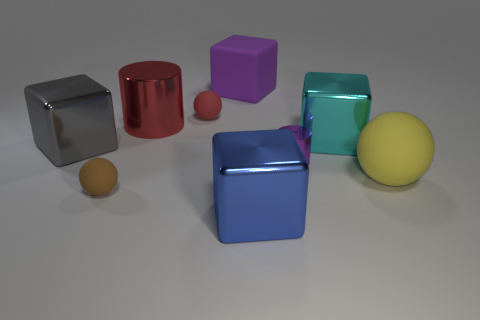Add 1 big gray cubes. How many objects exist? 10 Subtract all yellow cubes. Subtract all red cylinders. How many cubes are left? 4 Subtract all cylinders. How many objects are left? 7 Add 7 red metal things. How many red metal things exist? 8 Subtract 0 yellow cylinders. How many objects are left? 9 Subtract all big yellow spheres. Subtract all big spheres. How many objects are left? 7 Add 2 large gray things. How many large gray things are left? 3 